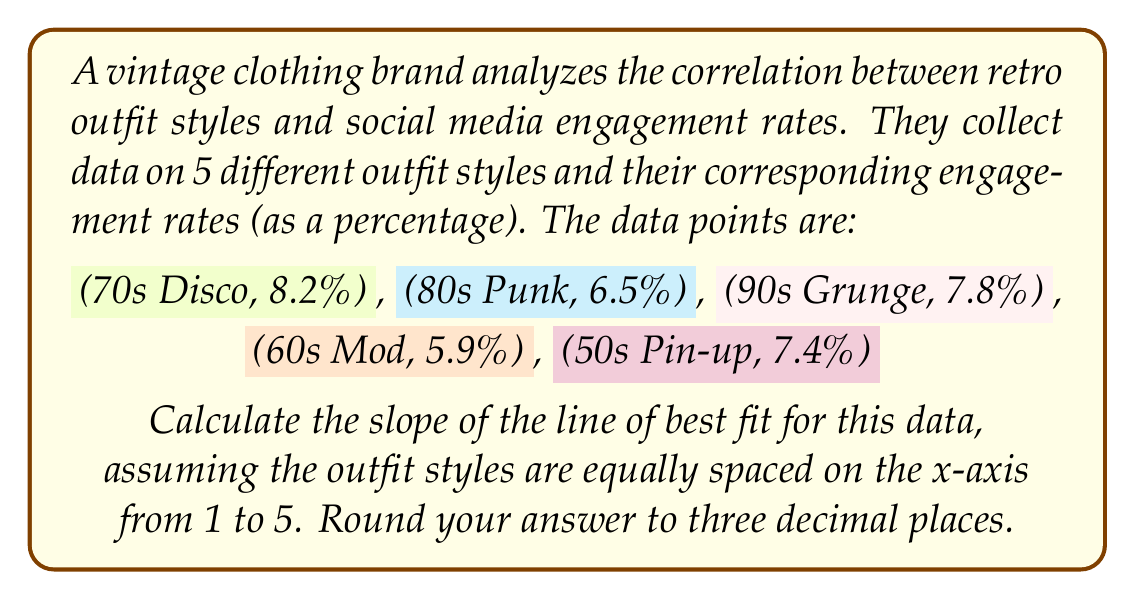Show me your answer to this math problem. To find the slope of the line of best fit, we'll use the formula:

$$ m = \frac{n\sum xy - \sum x \sum y}{n\sum x^2 - (\sum x)^2} $$

Where:
$n$ is the number of data points
$x$ represents the outfit style (1 to 5)
$y$ represents the engagement rate

Step 1: Prepare the data
Let's assign x-values from 1 to 5 for each style:
1: 50s Pin-up (7.4%)
2: 60s Mod (5.9%)
3: 70s Disco (8.2%)
4: 80s Punk (6.5%)
5: 90s Grunge (7.8%)

Step 2: Calculate the sums
$\sum x = 1 + 2 + 3 + 4 + 5 = 15$
$\sum y = 7.4 + 5.9 + 8.2 + 6.5 + 7.8 = 35.8$
$\sum xy = (1)(7.4) + (2)(5.9) + (3)(8.2) + (4)(6.5) + (5)(7.8) = 111.8$
$\sum x^2 = 1^2 + 2^2 + 3^2 + 4^2 + 5^2 = 55$

Step 3: Apply the formula
$$ m = \frac{5(111.8) - (15)(35.8)}{5(55) - (15)^2} $$
$$ m = \frac{559 - 537}{275 - 225} $$
$$ m = \frac{22}{50} = 0.44 $$

Step 4: Round to three decimal places
$m = 0.440$
Answer: 0.440 